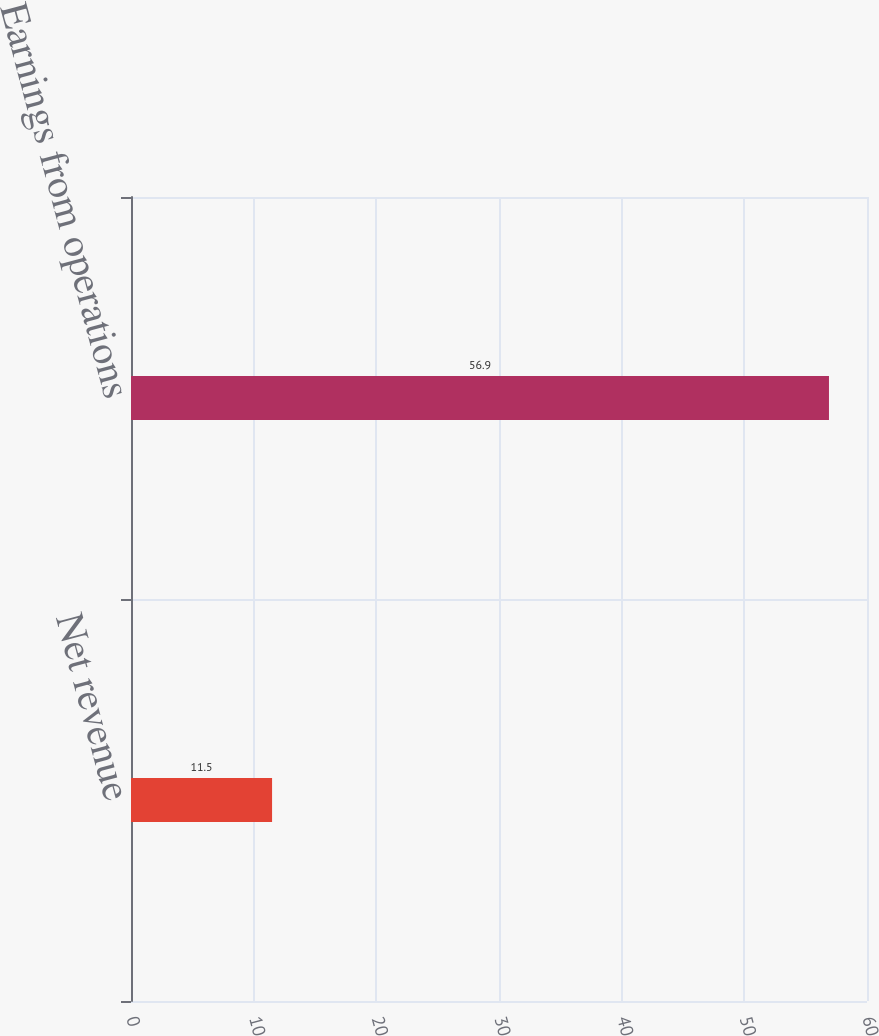Convert chart to OTSL. <chart><loc_0><loc_0><loc_500><loc_500><bar_chart><fcel>Net revenue<fcel>Earnings from operations<nl><fcel>11.5<fcel>56.9<nl></chart> 